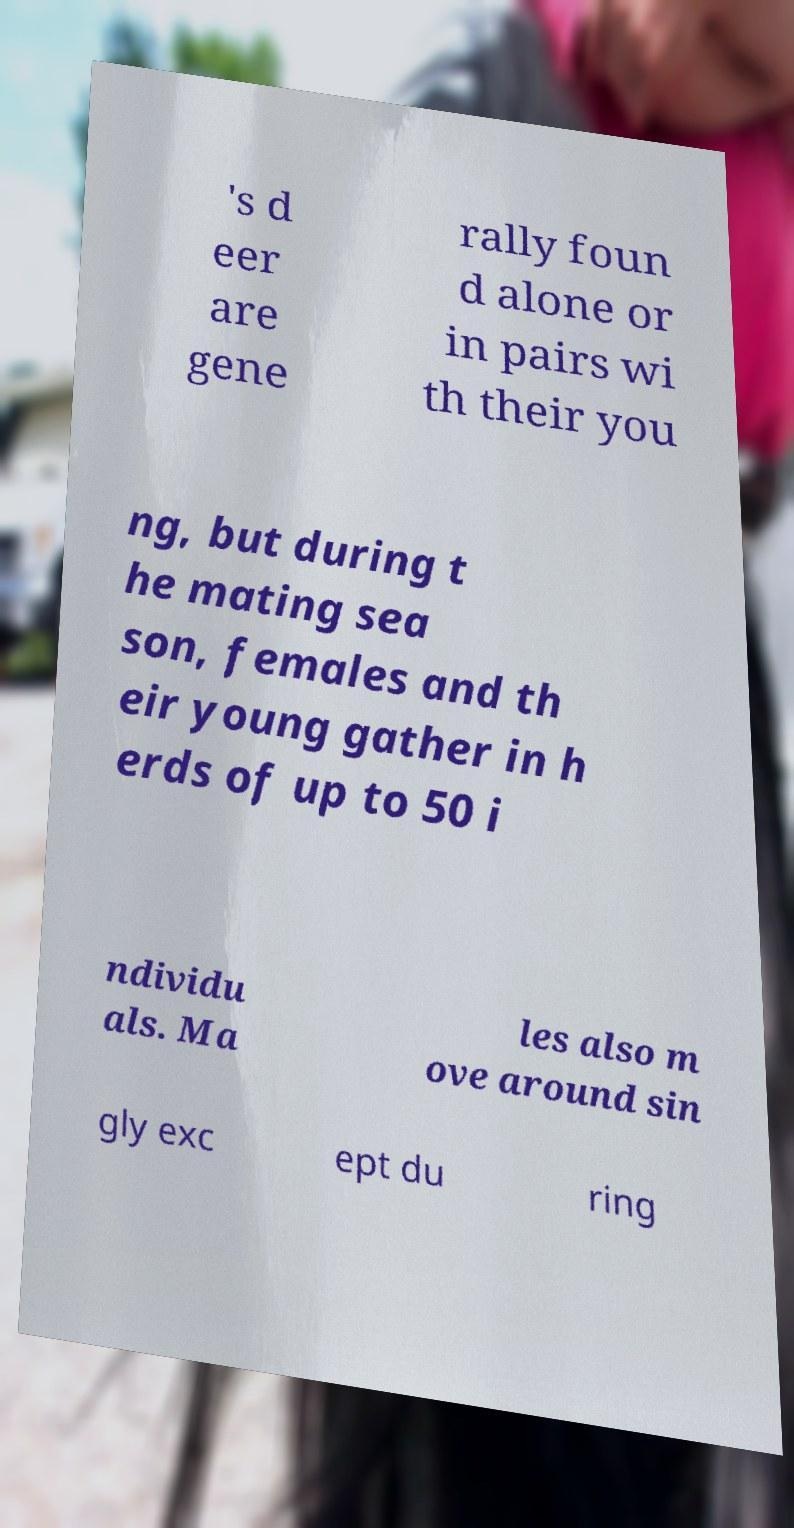What messages or text are displayed in this image? I need them in a readable, typed format. 's d eer are gene rally foun d alone or in pairs wi th their you ng, but during t he mating sea son, females and th eir young gather in h erds of up to 50 i ndividu als. Ma les also m ove around sin gly exc ept du ring 